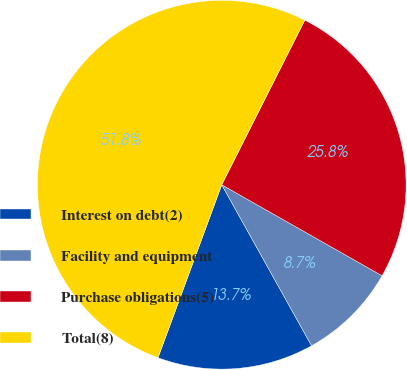Convert chart to OTSL. <chart><loc_0><loc_0><loc_500><loc_500><pie_chart><fcel>Interest on debt(2)<fcel>Facility and equipment<fcel>Purchase obligations(5)<fcel>Total(8)<nl><fcel>13.72%<fcel>8.68%<fcel>25.78%<fcel>51.82%<nl></chart> 